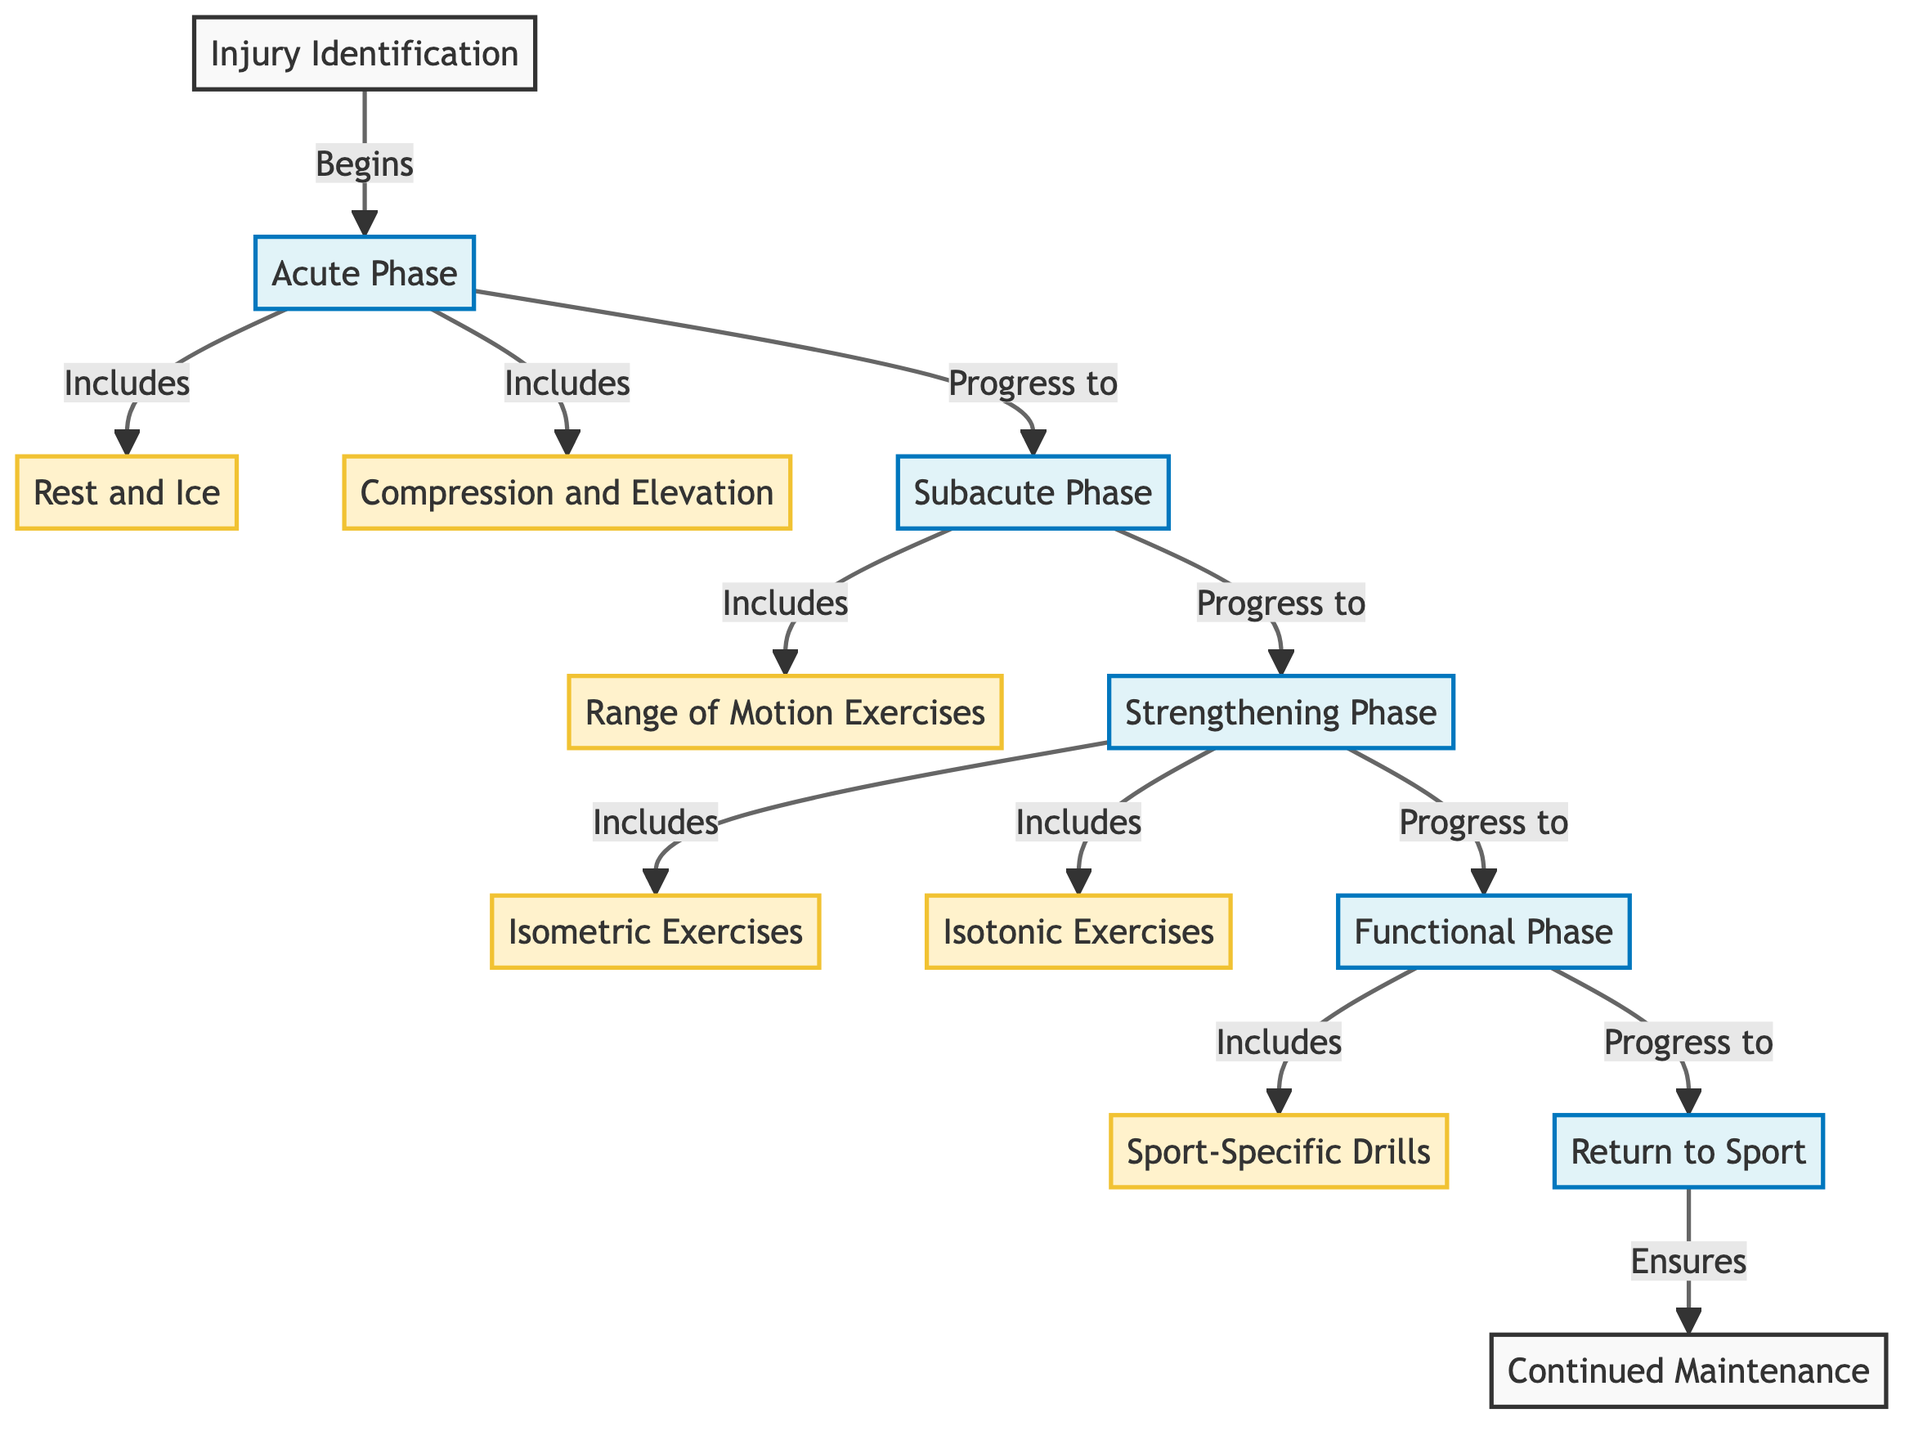What is the first step in the rehabilitation protocol? The first step in the flowchart is labeled "Injury Identification", which is the starting point for the rehabilitation process.
Answer: Injury Identification How many phases are in the rehabilitation protocol? The diagram has four main phases: Acute Phase, Subacute Phase, Strengthening Phase, and Functional Phase, making a total of four phases.
Answer: 4 What exercises are included in the Acute Phase? The Acute Phase includes two exercises: "Rest and Ice" and "Compression and Elevation", which are essential for initial treatment.
Answer: Rest and Ice, Compression and Elevation What is the last phase before returning to sport? The last phase before returning to sport is labeled "Functional Phase", which involves sport-specific drills to prepare for actual sports activity.
Answer: Functional Phase Which exercises are part of the Strengthening Phase? The Strengthening Phase includes two types of exercises: "Isometric Exercises" and "Isotonic Exercises", which help build strength.
Answer: Isometric Exercises, Isotonic Exercises What follows after the Range of Motion Exercises? After the "Range of Motion Exercises", the protocol progresses to the "Strengthening Phase", which indicates a focus on building strength following mobility work.
Answer: Strengthening Phase What ensures the "Continued Maintenance"? The final step, "Return to Sport", ensures "Continued Maintenance", indicating that after returning to sports, ongoing maintenance is necessary for recovery.
Answer: Return to Sport Which phase includes sport-specific drills? The "Functional Phase" includes "Sport-Specific Drills", emphasizing the importance of targeted practice for returning to the sport.
Answer: Functional Phase How is the relationship between the Subacute Phase and the Strengthening Phase? The diagram shows that the Subacute Phase progresses to the Strengthening Phase, indicating that after addressing mobility, the protocol moves toward strengthening.
Answer: Progress to 